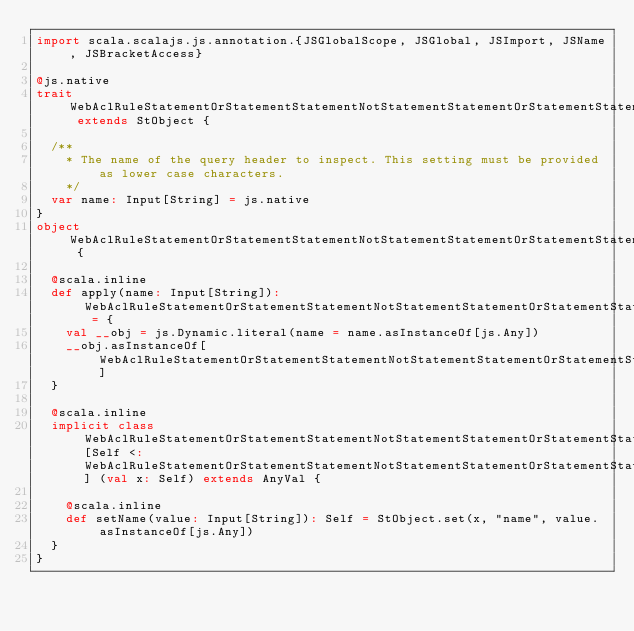Convert code to text. <code><loc_0><loc_0><loc_500><loc_500><_Scala_>import scala.scalajs.js.annotation.{JSGlobalScope, JSGlobal, JSImport, JSName, JSBracketAccess}

@js.native
trait WebAclRuleStatementOrStatementStatementNotStatementStatementOrStatementStatementXssMatchStatementFieldToMatchSingleHeader extends StObject {
  
  /**
    * The name of the query header to inspect. This setting must be provided as lower case characters.
    */
  var name: Input[String] = js.native
}
object WebAclRuleStatementOrStatementStatementNotStatementStatementOrStatementStatementXssMatchStatementFieldToMatchSingleHeader {
  
  @scala.inline
  def apply(name: Input[String]): WebAclRuleStatementOrStatementStatementNotStatementStatementOrStatementStatementXssMatchStatementFieldToMatchSingleHeader = {
    val __obj = js.Dynamic.literal(name = name.asInstanceOf[js.Any])
    __obj.asInstanceOf[WebAclRuleStatementOrStatementStatementNotStatementStatementOrStatementStatementXssMatchStatementFieldToMatchSingleHeader]
  }
  
  @scala.inline
  implicit class WebAclRuleStatementOrStatementStatementNotStatementStatementOrStatementStatementXssMatchStatementFieldToMatchSingleHeaderMutableBuilder[Self <: WebAclRuleStatementOrStatementStatementNotStatementStatementOrStatementStatementXssMatchStatementFieldToMatchSingleHeader] (val x: Self) extends AnyVal {
    
    @scala.inline
    def setName(value: Input[String]): Self = StObject.set(x, "name", value.asInstanceOf[js.Any])
  }
}
</code> 